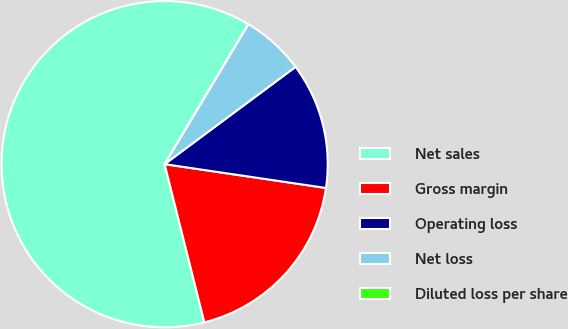<chart> <loc_0><loc_0><loc_500><loc_500><pie_chart><fcel>Net sales<fcel>Gross margin<fcel>Operating loss<fcel>Net loss<fcel>Diluted loss per share<nl><fcel>62.49%<fcel>18.75%<fcel>12.5%<fcel>6.25%<fcel>0.0%<nl></chart> 